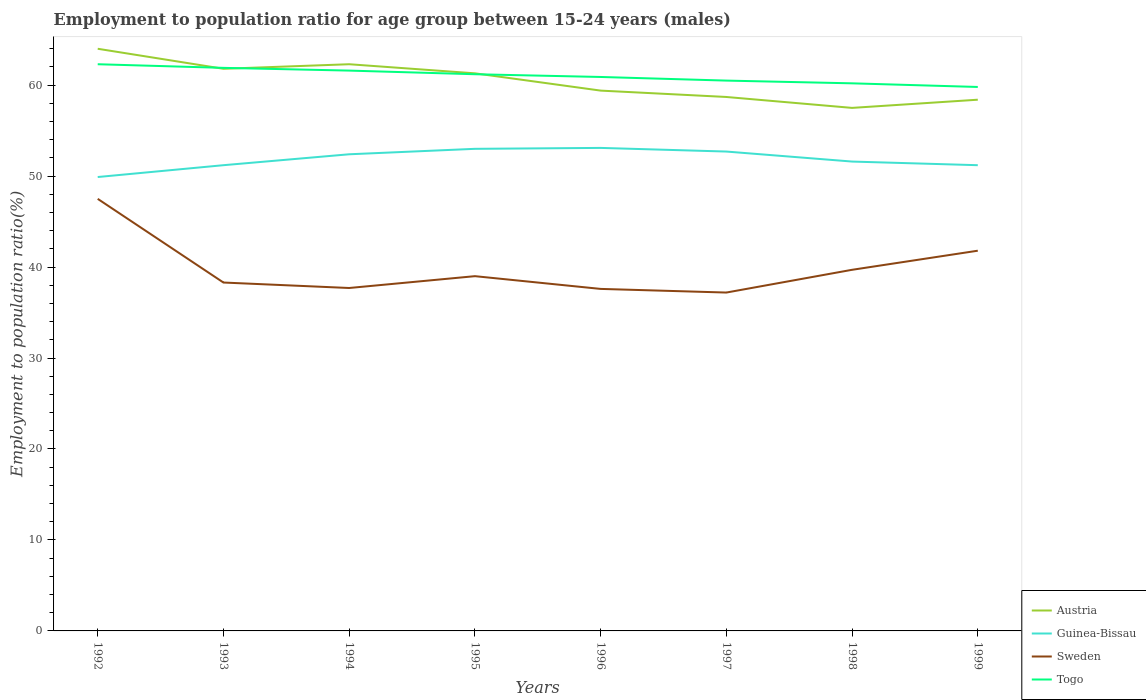How many different coloured lines are there?
Offer a terse response. 4. Across all years, what is the maximum employment to population ratio in Togo?
Your answer should be compact. 59.8. What is the total employment to population ratio in Austria in the graph?
Provide a succinct answer. 2.4. What is the difference between the highest and the second highest employment to population ratio in Guinea-Bissau?
Provide a succinct answer. 3.2. What is the difference between the highest and the lowest employment to population ratio in Austria?
Ensure brevity in your answer.  4. Is the employment to population ratio in Togo strictly greater than the employment to population ratio in Guinea-Bissau over the years?
Ensure brevity in your answer.  No. How many years are there in the graph?
Provide a succinct answer. 8. What is the difference between two consecutive major ticks on the Y-axis?
Keep it short and to the point. 10. Are the values on the major ticks of Y-axis written in scientific E-notation?
Provide a short and direct response. No. Does the graph contain grids?
Your answer should be compact. No. Where does the legend appear in the graph?
Your answer should be compact. Bottom right. How are the legend labels stacked?
Keep it short and to the point. Vertical. What is the title of the graph?
Your response must be concise. Employment to population ratio for age group between 15-24 years (males). What is the label or title of the X-axis?
Offer a terse response. Years. What is the Employment to population ratio(%) of Guinea-Bissau in 1992?
Your answer should be compact. 49.9. What is the Employment to population ratio(%) of Sweden in 1992?
Your answer should be compact. 47.5. What is the Employment to population ratio(%) in Togo in 1992?
Ensure brevity in your answer.  62.3. What is the Employment to population ratio(%) of Austria in 1993?
Give a very brief answer. 61.8. What is the Employment to population ratio(%) in Guinea-Bissau in 1993?
Give a very brief answer. 51.2. What is the Employment to population ratio(%) of Sweden in 1993?
Provide a succinct answer. 38.3. What is the Employment to population ratio(%) in Togo in 1993?
Offer a very short reply. 61.9. What is the Employment to population ratio(%) in Austria in 1994?
Your answer should be compact. 62.3. What is the Employment to population ratio(%) in Guinea-Bissau in 1994?
Ensure brevity in your answer.  52.4. What is the Employment to population ratio(%) of Sweden in 1994?
Your response must be concise. 37.7. What is the Employment to population ratio(%) of Togo in 1994?
Give a very brief answer. 61.6. What is the Employment to population ratio(%) of Austria in 1995?
Offer a very short reply. 61.3. What is the Employment to population ratio(%) in Sweden in 1995?
Provide a short and direct response. 39. What is the Employment to population ratio(%) in Togo in 1995?
Your answer should be very brief. 61.2. What is the Employment to population ratio(%) in Austria in 1996?
Keep it short and to the point. 59.4. What is the Employment to population ratio(%) of Guinea-Bissau in 1996?
Provide a short and direct response. 53.1. What is the Employment to population ratio(%) in Sweden in 1996?
Make the answer very short. 37.6. What is the Employment to population ratio(%) in Togo in 1996?
Keep it short and to the point. 60.9. What is the Employment to population ratio(%) in Austria in 1997?
Provide a short and direct response. 58.7. What is the Employment to population ratio(%) in Guinea-Bissau in 1997?
Offer a very short reply. 52.7. What is the Employment to population ratio(%) in Sweden in 1997?
Offer a terse response. 37.2. What is the Employment to population ratio(%) in Togo in 1997?
Your answer should be very brief. 60.5. What is the Employment to population ratio(%) in Austria in 1998?
Ensure brevity in your answer.  57.5. What is the Employment to population ratio(%) of Guinea-Bissau in 1998?
Offer a very short reply. 51.6. What is the Employment to population ratio(%) in Sweden in 1998?
Keep it short and to the point. 39.7. What is the Employment to population ratio(%) in Togo in 1998?
Make the answer very short. 60.2. What is the Employment to population ratio(%) in Austria in 1999?
Offer a very short reply. 58.4. What is the Employment to population ratio(%) in Guinea-Bissau in 1999?
Provide a succinct answer. 51.2. What is the Employment to population ratio(%) of Sweden in 1999?
Give a very brief answer. 41.8. What is the Employment to population ratio(%) in Togo in 1999?
Make the answer very short. 59.8. Across all years, what is the maximum Employment to population ratio(%) of Austria?
Offer a very short reply. 64. Across all years, what is the maximum Employment to population ratio(%) of Guinea-Bissau?
Provide a short and direct response. 53.1. Across all years, what is the maximum Employment to population ratio(%) of Sweden?
Offer a terse response. 47.5. Across all years, what is the maximum Employment to population ratio(%) of Togo?
Make the answer very short. 62.3. Across all years, what is the minimum Employment to population ratio(%) of Austria?
Provide a short and direct response. 57.5. Across all years, what is the minimum Employment to population ratio(%) in Guinea-Bissau?
Make the answer very short. 49.9. Across all years, what is the minimum Employment to population ratio(%) of Sweden?
Ensure brevity in your answer.  37.2. Across all years, what is the minimum Employment to population ratio(%) of Togo?
Provide a short and direct response. 59.8. What is the total Employment to population ratio(%) of Austria in the graph?
Your response must be concise. 483.4. What is the total Employment to population ratio(%) in Guinea-Bissau in the graph?
Provide a short and direct response. 415.1. What is the total Employment to population ratio(%) in Sweden in the graph?
Give a very brief answer. 318.8. What is the total Employment to population ratio(%) in Togo in the graph?
Keep it short and to the point. 488.4. What is the difference between the Employment to population ratio(%) in Austria in 1992 and that in 1993?
Your response must be concise. 2.2. What is the difference between the Employment to population ratio(%) of Guinea-Bissau in 1992 and that in 1993?
Give a very brief answer. -1.3. What is the difference between the Employment to population ratio(%) of Sweden in 1992 and that in 1993?
Your response must be concise. 9.2. What is the difference between the Employment to population ratio(%) in Austria in 1992 and that in 1994?
Offer a very short reply. 1.7. What is the difference between the Employment to population ratio(%) in Guinea-Bissau in 1992 and that in 1994?
Ensure brevity in your answer.  -2.5. What is the difference between the Employment to population ratio(%) of Sweden in 1992 and that in 1994?
Your answer should be compact. 9.8. What is the difference between the Employment to population ratio(%) in Guinea-Bissau in 1992 and that in 1995?
Make the answer very short. -3.1. What is the difference between the Employment to population ratio(%) in Sweden in 1992 and that in 1995?
Provide a short and direct response. 8.5. What is the difference between the Employment to population ratio(%) of Sweden in 1992 and that in 1996?
Provide a succinct answer. 9.9. What is the difference between the Employment to population ratio(%) in Togo in 1992 and that in 1996?
Offer a very short reply. 1.4. What is the difference between the Employment to population ratio(%) of Togo in 1992 and that in 1997?
Provide a succinct answer. 1.8. What is the difference between the Employment to population ratio(%) in Austria in 1992 and that in 1998?
Your answer should be compact. 6.5. What is the difference between the Employment to population ratio(%) in Guinea-Bissau in 1992 and that in 1998?
Give a very brief answer. -1.7. What is the difference between the Employment to population ratio(%) in Sweden in 1992 and that in 1998?
Offer a very short reply. 7.8. What is the difference between the Employment to population ratio(%) in Togo in 1992 and that in 1998?
Provide a succinct answer. 2.1. What is the difference between the Employment to population ratio(%) of Guinea-Bissau in 1992 and that in 1999?
Give a very brief answer. -1.3. What is the difference between the Employment to population ratio(%) in Sweden in 1992 and that in 1999?
Provide a short and direct response. 5.7. What is the difference between the Employment to population ratio(%) of Togo in 1992 and that in 1999?
Provide a succinct answer. 2.5. What is the difference between the Employment to population ratio(%) in Guinea-Bissau in 1993 and that in 1994?
Your answer should be compact. -1.2. What is the difference between the Employment to population ratio(%) of Sweden in 1993 and that in 1994?
Your answer should be compact. 0.6. What is the difference between the Employment to population ratio(%) in Togo in 1993 and that in 1994?
Offer a terse response. 0.3. What is the difference between the Employment to population ratio(%) of Austria in 1993 and that in 1995?
Provide a succinct answer. 0.5. What is the difference between the Employment to population ratio(%) in Guinea-Bissau in 1993 and that in 1995?
Offer a very short reply. -1.8. What is the difference between the Employment to population ratio(%) of Togo in 1993 and that in 1995?
Offer a very short reply. 0.7. What is the difference between the Employment to population ratio(%) in Austria in 1993 and that in 1996?
Your answer should be very brief. 2.4. What is the difference between the Employment to population ratio(%) in Guinea-Bissau in 1993 and that in 1997?
Ensure brevity in your answer.  -1.5. What is the difference between the Employment to population ratio(%) in Sweden in 1993 and that in 1997?
Give a very brief answer. 1.1. What is the difference between the Employment to population ratio(%) of Togo in 1993 and that in 1997?
Offer a very short reply. 1.4. What is the difference between the Employment to population ratio(%) in Austria in 1993 and that in 1998?
Your answer should be compact. 4.3. What is the difference between the Employment to population ratio(%) of Sweden in 1993 and that in 1998?
Give a very brief answer. -1.4. What is the difference between the Employment to population ratio(%) of Austria in 1993 and that in 1999?
Ensure brevity in your answer.  3.4. What is the difference between the Employment to population ratio(%) of Sweden in 1993 and that in 1999?
Make the answer very short. -3.5. What is the difference between the Employment to population ratio(%) in Austria in 1994 and that in 1995?
Your response must be concise. 1. What is the difference between the Employment to population ratio(%) in Austria in 1994 and that in 1996?
Give a very brief answer. 2.9. What is the difference between the Employment to population ratio(%) of Sweden in 1994 and that in 1996?
Ensure brevity in your answer.  0.1. What is the difference between the Employment to population ratio(%) of Togo in 1994 and that in 1996?
Provide a succinct answer. 0.7. What is the difference between the Employment to population ratio(%) in Guinea-Bissau in 1994 and that in 1997?
Your answer should be compact. -0.3. What is the difference between the Employment to population ratio(%) of Sweden in 1994 and that in 1997?
Your answer should be compact. 0.5. What is the difference between the Employment to population ratio(%) in Austria in 1994 and that in 1998?
Give a very brief answer. 4.8. What is the difference between the Employment to population ratio(%) of Austria in 1995 and that in 1996?
Offer a terse response. 1.9. What is the difference between the Employment to population ratio(%) in Sweden in 1995 and that in 1996?
Your answer should be very brief. 1.4. What is the difference between the Employment to population ratio(%) in Austria in 1995 and that in 1997?
Give a very brief answer. 2.6. What is the difference between the Employment to population ratio(%) of Sweden in 1995 and that in 1998?
Your answer should be compact. -0.7. What is the difference between the Employment to population ratio(%) of Togo in 1995 and that in 1998?
Keep it short and to the point. 1. What is the difference between the Employment to population ratio(%) in Austria in 1995 and that in 1999?
Make the answer very short. 2.9. What is the difference between the Employment to population ratio(%) of Guinea-Bissau in 1995 and that in 1999?
Provide a succinct answer. 1.8. What is the difference between the Employment to population ratio(%) in Sweden in 1995 and that in 1999?
Your answer should be compact. -2.8. What is the difference between the Employment to population ratio(%) in Togo in 1995 and that in 1999?
Your response must be concise. 1.4. What is the difference between the Employment to population ratio(%) in Guinea-Bissau in 1996 and that in 1997?
Your response must be concise. 0.4. What is the difference between the Employment to population ratio(%) in Sweden in 1996 and that in 1997?
Provide a succinct answer. 0.4. What is the difference between the Employment to population ratio(%) of Austria in 1996 and that in 1998?
Provide a short and direct response. 1.9. What is the difference between the Employment to population ratio(%) in Guinea-Bissau in 1996 and that in 1998?
Give a very brief answer. 1.5. What is the difference between the Employment to population ratio(%) of Austria in 1996 and that in 1999?
Your answer should be compact. 1. What is the difference between the Employment to population ratio(%) in Togo in 1996 and that in 1999?
Your answer should be very brief. 1.1. What is the difference between the Employment to population ratio(%) in Austria in 1997 and that in 1998?
Make the answer very short. 1.2. What is the difference between the Employment to population ratio(%) in Guinea-Bissau in 1997 and that in 1998?
Make the answer very short. 1.1. What is the difference between the Employment to population ratio(%) in Sweden in 1997 and that in 1998?
Your answer should be compact. -2.5. What is the difference between the Employment to population ratio(%) in Guinea-Bissau in 1997 and that in 1999?
Provide a succinct answer. 1.5. What is the difference between the Employment to population ratio(%) of Sweden in 1997 and that in 1999?
Offer a very short reply. -4.6. What is the difference between the Employment to population ratio(%) in Sweden in 1998 and that in 1999?
Make the answer very short. -2.1. What is the difference between the Employment to population ratio(%) in Austria in 1992 and the Employment to population ratio(%) in Sweden in 1993?
Your answer should be very brief. 25.7. What is the difference between the Employment to population ratio(%) of Austria in 1992 and the Employment to population ratio(%) of Togo in 1993?
Provide a succinct answer. 2.1. What is the difference between the Employment to population ratio(%) in Sweden in 1992 and the Employment to population ratio(%) in Togo in 1993?
Make the answer very short. -14.4. What is the difference between the Employment to population ratio(%) in Austria in 1992 and the Employment to population ratio(%) in Guinea-Bissau in 1994?
Provide a succinct answer. 11.6. What is the difference between the Employment to population ratio(%) of Austria in 1992 and the Employment to population ratio(%) of Sweden in 1994?
Keep it short and to the point. 26.3. What is the difference between the Employment to population ratio(%) of Austria in 1992 and the Employment to population ratio(%) of Togo in 1994?
Your answer should be very brief. 2.4. What is the difference between the Employment to population ratio(%) in Guinea-Bissau in 1992 and the Employment to population ratio(%) in Togo in 1994?
Your answer should be compact. -11.7. What is the difference between the Employment to population ratio(%) of Sweden in 1992 and the Employment to population ratio(%) of Togo in 1994?
Ensure brevity in your answer.  -14.1. What is the difference between the Employment to population ratio(%) in Austria in 1992 and the Employment to population ratio(%) in Sweden in 1995?
Provide a succinct answer. 25. What is the difference between the Employment to population ratio(%) of Guinea-Bissau in 1992 and the Employment to population ratio(%) of Togo in 1995?
Offer a very short reply. -11.3. What is the difference between the Employment to population ratio(%) of Sweden in 1992 and the Employment to population ratio(%) of Togo in 1995?
Make the answer very short. -13.7. What is the difference between the Employment to population ratio(%) of Austria in 1992 and the Employment to population ratio(%) of Guinea-Bissau in 1996?
Offer a very short reply. 10.9. What is the difference between the Employment to population ratio(%) of Austria in 1992 and the Employment to population ratio(%) of Sweden in 1996?
Make the answer very short. 26.4. What is the difference between the Employment to population ratio(%) of Sweden in 1992 and the Employment to population ratio(%) of Togo in 1996?
Ensure brevity in your answer.  -13.4. What is the difference between the Employment to population ratio(%) in Austria in 1992 and the Employment to population ratio(%) in Sweden in 1997?
Keep it short and to the point. 26.8. What is the difference between the Employment to population ratio(%) of Austria in 1992 and the Employment to population ratio(%) of Togo in 1997?
Offer a very short reply. 3.5. What is the difference between the Employment to population ratio(%) of Guinea-Bissau in 1992 and the Employment to population ratio(%) of Sweden in 1997?
Your answer should be very brief. 12.7. What is the difference between the Employment to population ratio(%) of Guinea-Bissau in 1992 and the Employment to population ratio(%) of Togo in 1997?
Make the answer very short. -10.6. What is the difference between the Employment to population ratio(%) in Sweden in 1992 and the Employment to population ratio(%) in Togo in 1997?
Offer a terse response. -13. What is the difference between the Employment to population ratio(%) of Austria in 1992 and the Employment to population ratio(%) of Sweden in 1998?
Provide a succinct answer. 24.3. What is the difference between the Employment to population ratio(%) of Guinea-Bissau in 1992 and the Employment to population ratio(%) of Sweden in 1998?
Your response must be concise. 10.2. What is the difference between the Employment to population ratio(%) of Guinea-Bissau in 1992 and the Employment to population ratio(%) of Togo in 1998?
Offer a very short reply. -10.3. What is the difference between the Employment to population ratio(%) of Austria in 1992 and the Employment to population ratio(%) of Guinea-Bissau in 1999?
Your answer should be compact. 12.8. What is the difference between the Employment to population ratio(%) of Guinea-Bissau in 1992 and the Employment to population ratio(%) of Togo in 1999?
Your response must be concise. -9.9. What is the difference between the Employment to population ratio(%) of Sweden in 1992 and the Employment to population ratio(%) of Togo in 1999?
Your answer should be very brief. -12.3. What is the difference between the Employment to population ratio(%) in Austria in 1993 and the Employment to population ratio(%) in Guinea-Bissau in 1994?
Your response must be concise. 9.4. What is the difference between the Employment to population ratio(%) in Austria in 1993 and the Employment to population ratio(%) in Sweden in 1994?
Give a very brief answer. 24.1. What is the difference between the Employment to population ratio(%) in Austria in 1993 and the Employment to population ratio(%) in Togo in 1994?
Your answer should be very brief. 0.2. What is the difference between the Employment to population ratio(%) of Guinea-Bissau in 1993 and the Employment to population ratio(%) of Sweden in 1994?
Keep it short and to the point. 13.5. What is the difference between the Employment to population ratio(%) in Sweden in 1993 and the Employment to population ratio(%) in Togo in 1994?
Keep it short and to the point. -23.3. What is the difference between the Employment to population ratio(%) of Austria in 1993 and the Employment to population ratio(%) of Guinea-Bissau in 1995?
Offer a very short reply. 8.8. What is the difference between the Employment to population ratio(%) in Austria in 1993 and the Employment to population ratio(%) in Sweden in 1995?
Offer a terse response. 22.8. What is the difference between the Employment to population ratio(%) of Austria in 1993 and the Employment to population ratio(%) of Togo in 1995?
Your answer should be compact. 0.6. What is the difference between the Employment to population ratio(%) in Guinea-Bissau in 1993 and the Employment to population ratio(%) in Togo in 1995?
Keep it short and to the point. -10. What is the difference between the Employment to population ratio(%) of Sweden in 1993 and the Employment to population ratio(%) of Togo in 1995?
Offer a terse response. -22.9. What is the difference between the Employment to population ratio(%) in Austria in 1993 and the Employment to population ratio(%) in Guinea-Bissau in 1996?
Provide a succinct answer. 8.7. What is the difference between the Employment to population ratio(%) of Austria in 1993 and the Employment to population ratio(%) of Sweden in 1996?
Offer a terse response. 24.2. What is the difference between the Employment to population ratio(%) in Sweden in 1993 and the Employment to population ratio(%) in Togo in 1996?
Make the answer very short. -22.6. What is the difference between the Employment to population ratio(%) in Austria in 1993 and the Employment to population ratio(%) in Sweden in 1997?
Your answer should be compact. 24.6. What is the difference between the Employment to population ratio(%) of Guinea-Bissau in 1993 and the Employment to population ratio(%) of Togo in 1997?
Your answer should be compact. -9.3. What is the difference between the Employment to population ratio(%) in Sweden in 1993 and the Employment to population ratio(%) in Togo in 1997?
Make the answer very short. -22.2. What is the difference between the Employment to population ratio(%) in Austria in 1993 and the Employment to population ratio(%) in Sweden in 1998?
Provide a succinct answer. 22.1. What is the difference between the Employment to population ratio(%) in Guinea-Bissau in 1993 and the Employment to population ratio(%) in Sweden in 1998?
Provide a succinct answer. 11.5. What is the difference between the Employment to population ratio(%) in Guinea-Bissau in 1993 and the Employment to population ratio(%) in Togo in 1998?
Offer a terse response. -9. What is the difference between the Employment to population ratio(%) of Sweden in 1993 and the Employment to population ratio(%) of Togo in 1998?
Your response must be concise. -21.9. What is the difference between the Employment to population ratio(%) in Austria in 1993 and the Employment to population ratio(%) in Guinea-Bissau in 1999?
Give a very brief answer. 10.6. What is the difference between the Employment to population ratio(%) in Austria in 1993 and the Employment to population ratio(%) in Togo in 1999?
Offer a terse response. 2. What is the difference between the Employment to population ratio(%) in Guinea-Bissau in 1993 and the Employment to population ratio(%) in Sweden in 1999?
Your response must be concise. 9.4. What is the difference between the Employment to population ratio(%) in Sweden in 1993 and the Employment to population ratio(%) in Togo in 1999?
Provide a short and direct response. -21.5. What is the difference between the Employment to population ratio(%) of Austria in 1994 and the Employment to population ratio(%) of Guinea-Bissau in 1995?
Make the answer very short. 9.3. What is the difference between the Employment to population ratio(%) in Austria in 1994 and the Employment to population ratio(%) in Sweden in 1995?
Your response must be concise. 23.3. What is the difference between the Employment to population ratio(%) of Guinea-Bissau in 1994 and the Employment to population ratio(%) of Sweden in 1995?
Offer a terse response. 13.4. What is the difference between the Employment to population ratio(%) in Sweden in 1994 and the Employment to population ratio(%) in Togo in 1995?
Make the answer very short. -23.5. What is the difference between the Employment to population ratio(%) in Austria in 1994 and the Employment to population ratio(%) in Guinea-Bissau in 1996?
Provide a succinct answer. 9.2. What is the difference between the Employment to population ratio(%) in Austria in 1994 and the Employment to population ratio(%) in Sweden in 1996?
Ensure brevity in your answer.  24.7. What is the difference between the Employment to population ratio(%) of Austria in 1994 and the Employment to population ratio(%) of Togo in 1996?
Offer a very short reply. 1.4. What is the difference between the Employment to population ratio(%) of Sweden in 1994 and the Employment to population ratio(%) of Togo in 1996?
Your answer should be very brief. -23.2. What is the difference between the Employment to population ratio(%) of Austria in 1994 and the Employment to population ratio(%) of Sweden in 1997?
Offer a terse response. 25.1. What is the difference between the Employment to population ratio(%) of Austria in 1994 and the Employment to population ratio(%) of Togo in 1997?
Provide a short and direct response. 1.8. What is the difference between the Employment to population ratio(%) of Guinea-Bissau in 1994 and the Employment to population ratio(%) of Sweden in 1997?
Your answer should be compact. 15.2. What is the difference between the Employment to population ratio(%) in Sweden in 1994 and the Employment to population ratio(%) in Togo in 1997?
Provide a short and direct response. -22.8. What is the difference between the Employment to population ratio(%) in Austria in 1994 and the Employment to population ratio(%) in Guinea-Bissau in 1998?
Your response must be concise. 10.7. What is the difference between the Employment to population ratio(%) of Austria in 1994 and the Employment to population ratio(%) of Sweden in 1998?
Your response must be concise. 22.6. What is the difference between the Employment to population ratio(%) in Austria in 1994 and the Employment to population ratio(%) in Togo in 1998?
Offer a very short reply. 2.1. What is the difference between the Employment to population ratio(%) in Guinea-Bissau in 1994 and the Employment to population ratio(%) in Sweden in 1998?
Offer a terse response. 12.7. What is the difference between the Employment to population ratio(%) of Sweden in 1994 and the Employment to population ratio(%) of Togo in 1998?
Keep it short and to the point. -22.5. What is the difference between the Employment to population ratio(%) of Austria in 1994 and the Employment to population ratio(%) of Guinea-Bissau in 1999?
Provide a succinct answer. 11.1. What is the difference between the Employment to population ratio(%) of Austria in 1994 and the Employment to population ratio(%) of Sweden in 1999?
Your answer should be very brief. 20.5. What is the difference between the Employment to population ratio(%) of Guinea-Bissau in 1994 and the Employment to population ratio(%) of Sweden in 1999?
Offer a terse response. 10.6. What is the difference between the Employment to population ratio(%) in Guinea-Bissau in 1994 and the Employment to population ratio(%) in Togo in 1999?
Keep it short and to the point. -7.4. What is the difference between the Employment to population ratio(%) in Sweden in 1994 and the Employment to population ratio(%) in Togo in 1999?
Offer a very short reply. -22.1. What is the difference between the Employment to population ratio(%) in Austria in 1995 and the Employment to population ratio(%) in Guinea-Bissau in 1996?
Keep it short and to the point. 8.2. What is the difference between the Employment to population ratio(%) in Austria in 1995 and the Employment to population ratio(%) in Sweden in 1996?
Your answer should be very brief. 23.7. What is the difference between the Employment to population ratio(%) of Sweden in 1995 and the Employment to population ratio(%) of Togo in 1996?
Keep it short and to the point. -21.9. What is the difference between the Employment to population ratio(%) in Austria in 1995 and the Employment to population ratio(%) in Sweden in 1997?
Offer a very short reply. 24.1. What is the difference between the Employment to population ratio(%) of Guinea-Bissau in 1995 and the Employment to population ratio(%) of Sweden in 1997?
Keep it short and to the point. 15.8. What is the difference between the Employment to population ratio(%) of Sweden in 1995 and the Employment to population ratio(%) of Togo in 1997?
Make the answer very short. -21.5. What is the difference between the Employment to population ratio(%) of Austria in 1995 and the Employment to population ratio(%) of Sweden in 1998?
Give a very brief answer. 21.6. What is the difference between the Employment to population ratio(%) in Guinea-Bissau in 1995 and the Employment to population ratio(%) in Sweden in 1998?
Offer a terse response. 13.3. What is the difference between the Employment to population ratio(%) of Sweden in 1995 and the Employment to population ratio(%) of Togo in 1998?
Provide a short and direct response. -21.2. What is the difference between the Employment to population ratio(%) of Austria in 1995 and the Employment to population ratio(%) of Guinea-Bissau in 1999?
Provide a succinct answer. 10.1. What is the difference between the Employment to population ratio(%) of Sweden in 1995 and the Employment to population ratio(%) of Togo in 1999?
Provide a short and direct response. -20.8. What is the difference between the Employment to population ratio(%) of Austria in 1996 and the Employment to population ratio(%) of Guinea-Bissau in 1997?
Your answer should be compact. 6.7. What is the difference between the Employment to population ratio(%) of Austria in 1996 and the Employment to population ratio(%) of Sweden in 1997?
Provide a short and direct response. 22.2. What is the difference between the Employment to population ratio(%) of Guinea-Bissau in 1996 and the Employment to population ratio(%) of Togo in 1997?
Your answer should be compact. -7.4. What is the difference between the Employment to population ratio(%) of Sweden in 1996 and the Employment to population ratio(%) of Togo in 1997?
Your answer should be very brief. -22.9. What is the difference between the Employment to population ratio(%) of Austria in 1996 and the Employment to population ratio(%) of Guinea-Bissau in 1998?
Your response must be concise. 7.8. What is the difference between the Employment to population ratio(%) of Guinea-Bissau in 1996 and the Employment to population ratio(%) of Sweden in 1998?
Ensure brevity in your answer.  13.4. What is the difference between the Employment to population ratio(%) of Sweden in 1996 and the Employment to population ratio(%) of Togo in 1998?
Offer a very short reply. -22.6. What is the difference between the Employment to population ratio(%) in Austria in 1996 and the Employment to population ratio(%) in Togo in 1999?
Your answer should be compact. -0.4. What is the difference between the Employment to population ratio(%) in Guinea-Bissau in 1996 and the Employment to population ratio(%) in Sweden in 1999?
Offer a very short reply. 11.3. What is the difference between the Employment to population ratio(%) of Guinea-Bissau in 1996 and the Employment to population ratio(%) of Togo in 1999?
Your answer should be compact. -6.7. What is the difference between the Employment to population ratio(%) in Sweden in 1996 and the Employment to population ratio(%) in Togo in 1999?
Provide a succinct answer. -22.2. What is the difference between the Employment to population ratio(%) of Austria in 1997 and the Employment to population ratio(%) of Togo in 1998?
Your answer should be very brief. -1.5. What is the difference between the Employment to population ratio(%) in Austria in 1997 and the Employment to population ratio(%) in Sweden in 1999?
Your answer should be very brief. 16.9. What is the difference between the Employment to population ratio(%) of Austria in 1997 and the Employment to population ratio(%) of Togo in 1999?
Provide a short and direct response. -1.1. What is the difference between the Employment to population ratio(%) of Guinea-Bissau in 1997 and the Employment to population ratio(%) of Sweden in 1999?
Your answer should be compact. 10.9. What is the difference between the Employment to population ratio(%) in Sweden in 1997 and the Employment to population ratio(%) in Togo in 1999?
Provide a short and direct response. -22.6. What is the difference between the Employment to population ratio(%) of Austria in 1998 and the Employment to population ratio(%) of Togo in 1999?
Keep it short and to the point. -2.3. What is the difference between the Employment to population ratio(%) of Sweden in 1998 and the Employment to population ratio(%) of Togo in 1999?
Keep it short and to the point. -20.1. What is the average Employment to population ratio(%) of Austria per year?
Your response must be concise. 60.42. What is the average Employment to population ratio(%) of Guinea-Bissau per year?
Offer a very short reply. 51.89. What is the average Employment to population ratio(%) of Sweden per year?
Ensure brevity in your answer.  39.85. What is the average Employment to population ratio(%) of Togo per year?
Your answer should be compact. 61.05. In the year 1992, what is the difference between the Employment to population ratio(%) in Austria and Employment to population ratio(%) in Togo?
Make the answer very short. 1.7. In the year 1992, what is the difference between the Employment to population ratio(%) in Guinea-Bissau and Employment to population ratio(%) in Sweden?
Your answer should be very brief. 2.4. In the year 1992, what is the difference between the Employment to population ratio(%) in Guinea-Bissau and Employment to population ratio(%) in Togo?
Offer a very short reply. -12.4. In the year 1992, what is the difference between the Employment to population ratio(%) in Sweden and Employment to population ratio(%) in Togo?
Your answer should be compact. -14.8. In the year 1993, what is the difference between the Employment to population ratio(%) of Austria and Employment to population ratio(%) of Sweden?
Offer a terse response. 23.5. In the year 1993, what is the difference between the Employment to population ratio(%) in Guinea-Bissau and Employment to population ratio(%) in Togo?
Make the answer very short. -10.7. In the year 1993, what is the difference between the Employment to population ratio(%) in Sweden and Employment to population ratio(%) in Togo?
Your answer should be compact. -23.6. In the year 1994, what is the difference between the Employment to population ratio(%) of Austria and Employment to population ratio(%) of Guinea-Bissau?
Your answer should be very brief. 9.9. In the year 1994, what is the difference between the Employment to population ratio(%) in Austria and Employment to population ratio(%) in Sweden?
Your answer should be compact. 24.6. In the year 1994, what is the difference between the Employment to population ratio(%) of Austria and Employment to population ratio(%) of Togo?
Your answer should be very brief. 0.7. In the year 1994, what is the difference between the Employment to population ratio(%) in Guinea-Bissau and Employment to population ratio(%) in Togo?
Provide a short and direct response. -9.2. In the year 1994, what is the difference between the Employment to population ratio(%) of Sweden and Employment to population ratio(%) of Togo?
Make the answer very short. -23.9. In the year 1995, what is the difference between the Employment to population ratio(%) of Austria and Employment to population ratio(%) of Guinea-Bissau?
Offer a terse response. 8.3. In the year 1995, what is the difference between the Employment to population ratio(%) in Austria and Employment to population ratio(%) in Sweden?
Your response must be concise. 22.3. In the year 1995, what is the difference between the Employment to population ratio(%) of Guinea-Bissau and Employment to population ratio(%) of Sweden?
Offer a very short reply. 14. In the year 1995, what is the difference between the Employment to population ratio(%) in Sweden and Employment to population ratio(%) in Togo?
Your response must be concise. -22.2. In the year 1996, what is the difference between the Employment to population ratio(%) of Austria and Employment to population ratio(%) of Guinea-Bissau?
Keep it short and to the point. 6.3. In the year 1996, what is the difference between the Employment to population ratio(%) of Austria and Employment to population ratio(%) of Sweden?
Keep it short and to the point. 21.8. In the year 1996, what is the difference between the Employment to population ratio(%) of Austria and Employment to population ratio(%) of Togo?
Your response must be concise. -1.5. In the year 1996, what is the difference between the Employment to population ratio(%) in Guinea-Bissau and Employment to population ratio(%) in Togo?
Offer a terse response. -7.8. In the year 1996, what is the difference between the Employment to population ratio(%) in Sweden and Employment to population ratio(%) in Togo?
Offer a terse response. -23.3. In the year 1997, what is the difference between the Employment to population ratio(%) of Austria and Employment to population ratio(%) of Guinea-Bissau?
Offer a very short reply. 6. In the year 1997, what is the difference between the Employment to population ratio(%) of Guinea-Bissau and Employment to population ratio(%) of Togo?
Keep it short and to the point. -7.8. In the year 1997, what is the difference between the Employment to population ratio(%) of Sweden and Employment to population ratio(%) of Togo?
Ensure brevity in your answer.  -23.3. In the year 1998, what is the difference between the Employment to population ratio(%) of Austria and Employment to population ratio(%) of Togo?
Provide a succinct answer. -2.7. In the year 1998, what is the difference between the Employment to population ratio(%) in Guinea-Bissau and Employment to population ratio(%) in Sweden?
Provide a short and direct response. 11.9. In the year 1998, what is the difference between the Employment to population ratio(%) in Sweden and Employment to population ratio(%) in Togo?
Make the answer very short. -20.5. In the year 1999, what is the difference between the Employment to population ratio(%) in Austria and Employment to population ratio(%) in Sweden?
Give a very brief answer. 16.6. In the year 1999, what is the difference between the Employment to population ratio(%) of Guinea-Bissau and Employment to population ratio(%) of Sweden?
Offer a very short reply. 9.4. In the year 1999, what is the difference between the Employment to population ratio(%) of Sweden and Employment to population ratio(%) of Togo?
Your response must be concise. -18. What is the ratio of the Employment to population ratio(%) of Austria in 1992 to that in 1993?
Offer a very short reply. 1.04. What is the ratio of the Employment to population ratio(%) of Guinea-Bissau in 1992 to that in 1993?
Your response must be concise. 0.97. What is the ratio of the Employment to population ratio(%) of Sweden in 1992 to that in 1993?
Make the answer very short. 1.24. What is the ratio of the Employment to population ratio(%) of Austria in 1992 to that in 1994?
Ensure brevity in your answer.  1.03. What is the ratio of the Employment to population ratio(%) in Guinea-Bissau in 1992 to that in 1994?
Offer a terse response. 0.95. What is the ratio of the Employment to population ratio(%) in Sweden in 1992 to that in 1994?
Provide a short and direct response. 1.26. What is the ratio of the Employment to population ratio(%) of Togo in 1992 to that in 1994?
Your answer should be very brief. 1.01. What is the ratio of the Employment to population ratio(%) of Austria in 1992 to that in 1995?
Keep it short and to the point. 1.04. What is the ratio of the Employment to population ratio(%) in Guinea-Bissau in 1992 to that in 1995?
Keep it short and to the point. 0.94. What is the ratio of the Employment to population ratio(%) of Sweden in 1992 to that in 1995?
Your answer should be compact. 1.22. What is the ratio of the Employment to population ratio(%) in Austria in 1992 to that in 1996?
Your response must be concise. 1.08. What is the ratio of the Employment to population ratio(%) in Guinea-Bissau in 1992 to that in 1996?
Give a very brief answer. 0.94. What is the ratio of the Employment to population ratio(%) of Sweden in 1992 to that in 1996?
Ensure brevity in your answer.  1.26. What is the ratio of the Employment to population ratio(%) of Togo in 1992 to that in 1996?
Offer a very short reply. 1.02. What is the ratio of the Employment to population ratio(%) in Austria in 1992 to that in 1997?
Give a very brief answer. 1.09. What is the ratio of the Employment to population ratio(%) of Guinea-Bissau in 1992 to that in 1997?
Keep it short and to the point. 0.95. What is the ratio of the Employment to population ratio(%) in Sweden in 1992 to that in 1997?
Your answer should be very brief. 1.28. What is the ratio of the Employment to population ratio(%) in Togo in 1992 to that in 1997?
Keep it short and to the point. 1.03. What is the ratio of the Employment to population ratio(%) of Austria in 1992 to that in 1998?
Provide a succinct answer. 1.11. What is the ratio of the Employment to population ratio(%) of Guinea-Bissau in 1992 to that in 1998?
Give a very brief answer. 0.97. What is the ratio of the Employment to population ratio(%) of Sweden in 1992 to that in 1998?
Give a very brief answer. 1.2. What is the ratio of the Employment to population ratio(%) in Togo in 1992 to that in 1998?
Ensure brevity in your answer.  1.03. What is the ratio of the Employment to population ratio(%) in Austria in 1992 to that in 1999?
Provide a short and direct response. 1.1. What is the ratio of the Employment to population ratio(%) of Guinea-Bissau in 1992 to that in 1999?
Provide a succinct answer. 0.97. What is the ratio of the Employment to population ratio(%) of Sweden in 1992 to that in 1999?
Your response must be concise. 1.14. What is the ratio of the Employment to population ratio(%) of Togo in 1992 to that in 1999?
Offer a very short reply. 1.04. What is the ratio of the Employment to population ratio(%) in Austria in 1993 to that in 1994?
Your response must be concise. 0.99. What is the ratio of the Employment to population ratio(%) in Guinea-Bissau in 1993 to that in 1994?
Your answer should be very brief. 0.98. What is the ratio of the Employment to population ratio(%) in Sweden in 1993 to that in 1994?
Your answer should be compact. 1.02. What is the ratio of the Employment to population ratio(%) in Austria in 1993 to that in 1995?
Your answer should be very brief. 1.01. What is the ratio of the Employment to population ratio(%) of Guinea-Bissau in 1993 to that in 1995?
Your answer should be very brief. 0.97. What is the ratio of the Employment to population ratio(%) in Sweden in 1993 to that in 1995?
Ensure brevity in your answer.  0.98. What is the ratio of the Employment to population ratio(%) of Togo in 1993 to that in 1995?
Provide a succinct answer. 1.01. What is the ratio of the Employment to population ratio(%) of Austria in 1993 to that in 1996?
Keep it short and to the point. 1.04. What is the ratio of the Employment to population ratio(%) of Guinea-Bissau in 1993 to that in 1996?
Offer a very short reply. 0.96. What is the ratio of the Employment to population ratio(%) of Sweden in 1993 to that in 1996?
Make the answer very short. 1.02. What is the ratio of the Employment to population ratio(%) of Togo in 1993 to that in 1996?
Offer a terse response. 1.02. What is the ratio of the Employment to population ratio(%) in Austria in 1993 to that in 1997?
Your answer should be compact. 1.05. What is the ratio of the Employment to population ratio(%) of Guinea-Bissau in 1993 to that in 1997?
Make the answer very short. 0.97. What is the ratio of the Employment to population ratio(%) of Sweden in 1993 to that in 1997?
Your answer should be very brief. 1.03. What is the ratio of the Employment to population ratio(%) in Togo in 1993 to that in 1997?
Offer a very short reply. 1.02. What is the ratio of the Employment to population ratio(%) of Austria in 1993 to that in 1998?
Ensure brevity in your answer.  1.07. What is the ratio of the Employment to population ratio(%) in Sweden in 1993 to that in 1998?
Make the answer very short. 0.96. What is the ratio of the Employment to population ratio(%) of Togo in 1993 to that in 1998?
Give a very brief answer. 1.03. What is the ratio of the Employment to population ratio(%) of Austria in 1993 to that in 1999?
Offer a very short reply. 1.06. What is the ratio of the Employment to population ratio(%) in Guinea-Bissau in 1993 to that in 1999?
Provide a short and direct response. 1. What is the ratio of the Employment to population ratio(%) in Sweden in 1993 to that in 1999?
Your answer should be very brief. 0.92. What is the ratio of the Employment to population ratio(%) of Togo in 1993 to that in 1999?
Make the answer very short. 1.04. What is the ratio of the Employment to population ratio(%) in Austria in 1994 to that in 1995?
Your response must be concise. 1.02. What is the ratio of the Employment to population ratio(%) of Guinea-Bissau in 1994 to that in 1995?
Your answer should be compact. 0.99. What is the ratio of the Employment to population ratio(%) in Sweden in 1994 to that in 1995?
Make the answer very short. 0.97. What is the ratio of the Employment to population ratio(%) in Austria in 1994 to that in 1996?
Keep it short and to the point. 1.05. What is the ratio of the Employment to population ratio(%) in Guinea-Bissau in 1994 to that in 1996?
Your answer should be very brief. 0.99. What is the ratio of the Employment to population ratio(%) in Sweden in 1994 to that in 1996?
Give a very brief answer. 1. What is the ratio of the Employment to population ratio(%) in Togo in 1994 to that in 1996?
Offer a very short reply. 1.01. What is the ratio of the Employment to population ratio(%) of Austria in 1994 to that in 1997?
Offer a terse response. 1.06. What is the ratio of the Employment to population ratio(%) in Guinea-Bissau in 1994 to that in 1997?
Your response must be concise. 0.99. What is the ratio of the Employment to population ratio(%) of Sweden in 1994 to that in 1997?
Your response must be concise. 1.01. What is the ratio of the Employment to population ratio(%) in Togo in 1994 to that in 1997?
Your answer should be very brief. 1.02. What is the ratio of the Employment to population ratio(%) in Austria in 1994 to that in 1998?
Offer a very short reply. 1.08. What is the ratio of the Employment to population ratio(%) in Guinea-Bissau in 1994 to that in 1998?
Offer a terse response. 1.02. What is the ratio of the Employment to population ratio(%) in Sweden in 1994 to that in 1998?
Your response must be concise. 0.95. What is the ratio of the Employment to population ratio(%) of Togo in 1994 to that in 1998?
Make the answer very short. 1.02. What is the ratio of the Employment to population ratio(%) of Austria in 1994 to that in 1999?
Provide a succinct answer. 1.07. What is the ratio of the Employment to population ratio(%) of Guinea-Bissau in 1994 to that in 1999?
Provide a short and direct response. 1.02. What is the ratio of the Employment to population ratio(%) of Sweden in 1994 to that in 1999?
Your answer should be compact. 0.9. What is the ratio of the Employment to population ratio(%) in Togo in 1994 to that in 1999?
Your response must be concise. 1.03. What is the ratio of the Employment to population ratio(%) of Austria in 1995 to that in 1996?
Offer a terse response. 1.03. What is the ratio of the Employment to population ratio(%) in Sweden in 1995 to that in 1996?
Offer a terse response. 1.04. What is the ratio of the Employment to population ratio(%) in Togo in 1995 to that in 1996?
Your answer should be very brief. 1. What is the ratio of the Employment to population ratio(%) of Austria in 1995 to that in 1997?
Make the answer very short. 1.04. What is the ratio of the Employment to population ratio(%) in Guinea-Bissau in 1995 to that in 1997?
Your response must be concise. 1.01. What is the ratio of the Employment to population ratio(%) in Sweden in 1995 to that in 1997?
Offer a terse response. 1.05. What is the ratio of the Employment to population ratio(%) of Togo in 1995 to that in 1997?
Give a very brief answer. 1.01. What is the ratio of the Employment to population ratio(%) of Austria in 1995 to that in 1998?
Provide a succinct answer. 1.07. What is the ratio of the Employment to population ratio(%) of Guinea-Bissau in 1995 to that in 1998?
Your response must be concise. 1.03. What is the ratio of the Employment to population ratio(%) in Sweden in 1995 to that in 1998?
Offer a very short reply. 0.98. What is the ratio of the Employment to population ratio(%) in Togo in 1995 to that in 1998?
Your response must be concise. 1.02. What is the ratio of the Employment to population ratio(%) of Austria in 1995 to that in 1999?
Give a very brief answer. 1.05. What is the ratio of the Employment to population ratio(%) in Guinea-Bissau in 1995 to that in 1999?
Provide a succinct answer. 1.04. What is the ratio of the Employment to population ratio(%) in Sweden in 1995 to that in 1999?
Make the answer very short. 0.93. What is the ratio of the Employment to population ratio(%) in Togo in 1995 to that in 1999?
Ensure brevity in your answer.  1.02. What is the ratio of the Employment to population ratio(%) of Austria in 1996 to that in 1997?
Your answer should be very brief. 1.01. What is the ratio of the Employment to population ratio(%) in Guinea-Bissau in 1996 to that in 1997?
Offer a very short reply. 1.01. What is the ratio of the Employment to population ratio(%) of Sweden in 1996 to that in 1997?
Your response must be concise. 1.01. What is the ratio of the Employment to population ratio(%) of Togo in 1996 to that in 1997?
Keep it short and to the point. 1.01. What is the ratio of the Employment to population ratio(%) in Austria in 1996 to that in 1998?
Make the answer very short. 1.03. What is the ratio of the Employment to population ratio(%) of Guinea-Bissau in 1996 to that in 1998?
Your answer should be very brief. 1.03. What is the ratio of the Employment to population ratio(%) of Sweden in 1996 to that in 1998?
Give a very brief answer. 0.95. What is the ratio of the Employment to population ratio(%) in Togo in 1996 to that in 1998?
Your response must be concise. 1.01. What is the ratio of the Employment to population ratio(%) of Austria in 1996 to that in 1999?
Ensure brevity in your answer.  1.02. What is the ratio of the Employment to population ratio(%) of Guinea-Bissau in 1996 to that in 1999?
Your answer should be very brief. 1.04. What is the ratio of the Employment to population ratio(%) in Sweden in 1996 to that in 1999?
Your answer should be very brief. 0.9. What is the ratio of the Employment to population ratio(%) of Togo in 1996 to that in 1999?
Your answer should be compact. 1.02. What is the ratio of the Employment to population ratio(%) of Austria in 1997 to that in 1998?
Make the answer very short. 1.02. What is the ratio of the Employment to population ratio(%) in Guinea-Bissau in 1997 to that in 1998?
Provide a short and direct response. 1.02. What is the ratio of the Employment to population ratio(%) of Sweden in 1997 to that in 1998?
Offer a very short reply. 0.94. What is the ratio of the Employment to population ratio(%) in Togo in 1997 to that in 1998?
Your response must be concise. 1. What is the ratio of the Employment to population ratio(%) of Austria in 1997 to that in 1999?
Make the answer very short. 1.01. What is the ratio of the Employment to population ratio(%) in Guinea-Bissau in 1997 to that in 1999?
Offer a terse response. 1.03. What is the ratio of the Employment to population ratio(%) of Sweden in 1997 to that in 1999?
Give a very brief answer. 0.89. What is the ratio of the Employment to population ratio(%) in Togo in 1997 to that in 1999?
Provide a short and direct response. 1.01. What is the ratio of the Employment to population ratio(%) of Austria in 1998 to that in 1999?
Give a very brief answer. 0.98. What is the ratio of the Employment to population ratio(%) of Guinea-Bissau in 1998 to that in 1999?
Offer a terse response. 1.01. What is the ratio of the Employment to population ratio(%) in Sweden in 1998 to that in 1999?
Your answer should be compact. 0.95. What is the ratio of the Employment to population ratio(%) in Togo in 1998 to that in 1999?
Keep it short and to the point. 1.01. What is the difference between the highest and the second highest Employment to population ratio(%) in Sweden?
Your answer should be compact. 5.7. What is the difference between the highest and the second highest Employment to population ratio(%) in Togo?
Your answer should be very brief. 0.4. What is the difference between the highest and the lowest Employment to population ratio(%) in Austria?
Provide a short and direct response. 6.5. What is the difference between the highest and the lowest Employment to population ratio(%) of Sweden?
Your answer should be very brief. 10.3. What is the difference between the highest and the lowest Employment to population ratio(%) in Togo?
Offer a very short reply. 2.5. 